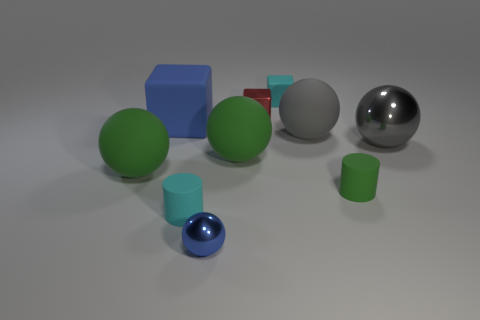There is a object that is the same color as the tiny sphere; what is its material?
Your answer should be very brief. Rubber. Is the shape of the blue matte thing the same as the tiny shiny object that is in front of the small green cylinder?
Your answer should be very brief. No. What number of other things are there of the same material as the green cylinder
Offer a very short reply. 6. There is a large cube; does it have the same color as the metallic thing in front of the green matte cylinder?
Your answer should be compact. Yes. There is a ball right of the tiny green thing; what is its material?
Your answer should be compact. Metal. Are there any tiny metallic balls of the same color as the tiny metallic block?
Give a very brief answer. No. The metallic block that is the same size as the blue metal object is what color?
Provide a short and direct response. Red. What number of large objects are cyan shiny cubes or green rubber cylinders?
Ensure brevity in your answer.  0. Are there the same number of large rubber cubes to the right of the red metallic block and tiny blue things that are on the left side of the cyan rubber cylinder?
Your answer should be compact. Yes. How many cyan cylinders have the same size as the green cylinder?
Ensure brevity in your answer.  1. 